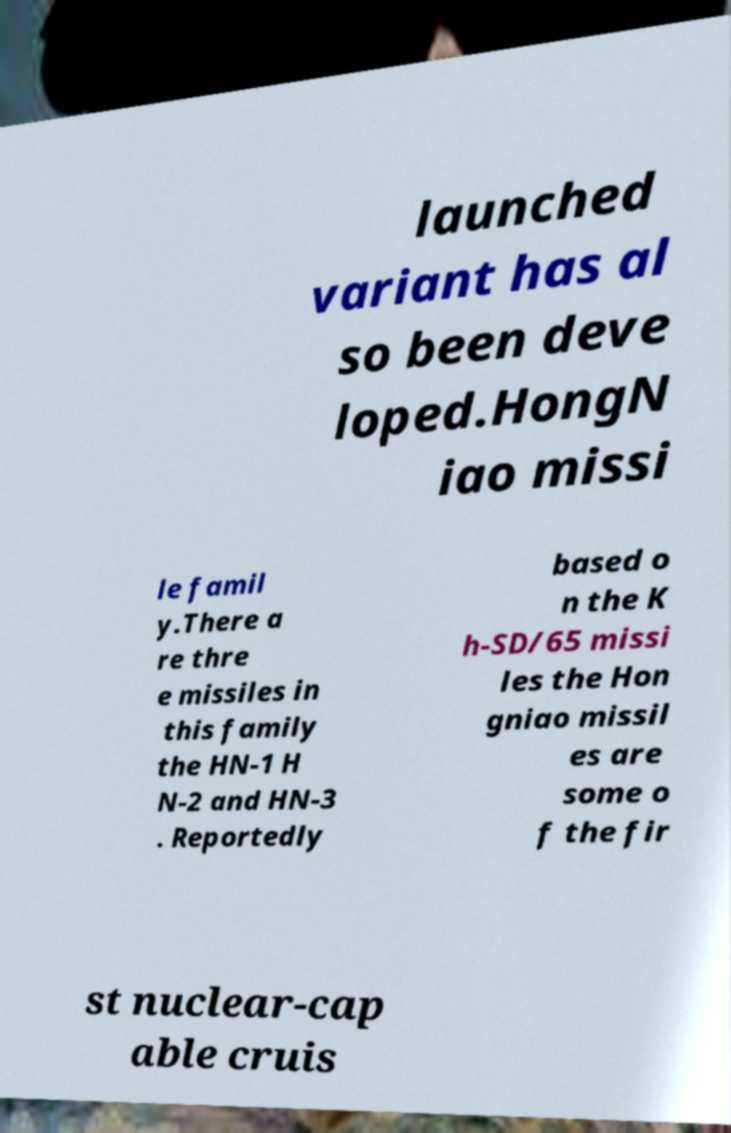Please identify and transcribe the text found in this image. launched variant has al so been deve loped.HongN iao missi le famil y.There a re thre e missiles in this family the HN-1 H N-2 and HN-3 . Reportedly based o n the K h-SD/65 missi les the Hon gniao missil es are some o f the fir st nuclear-cap able cruis 